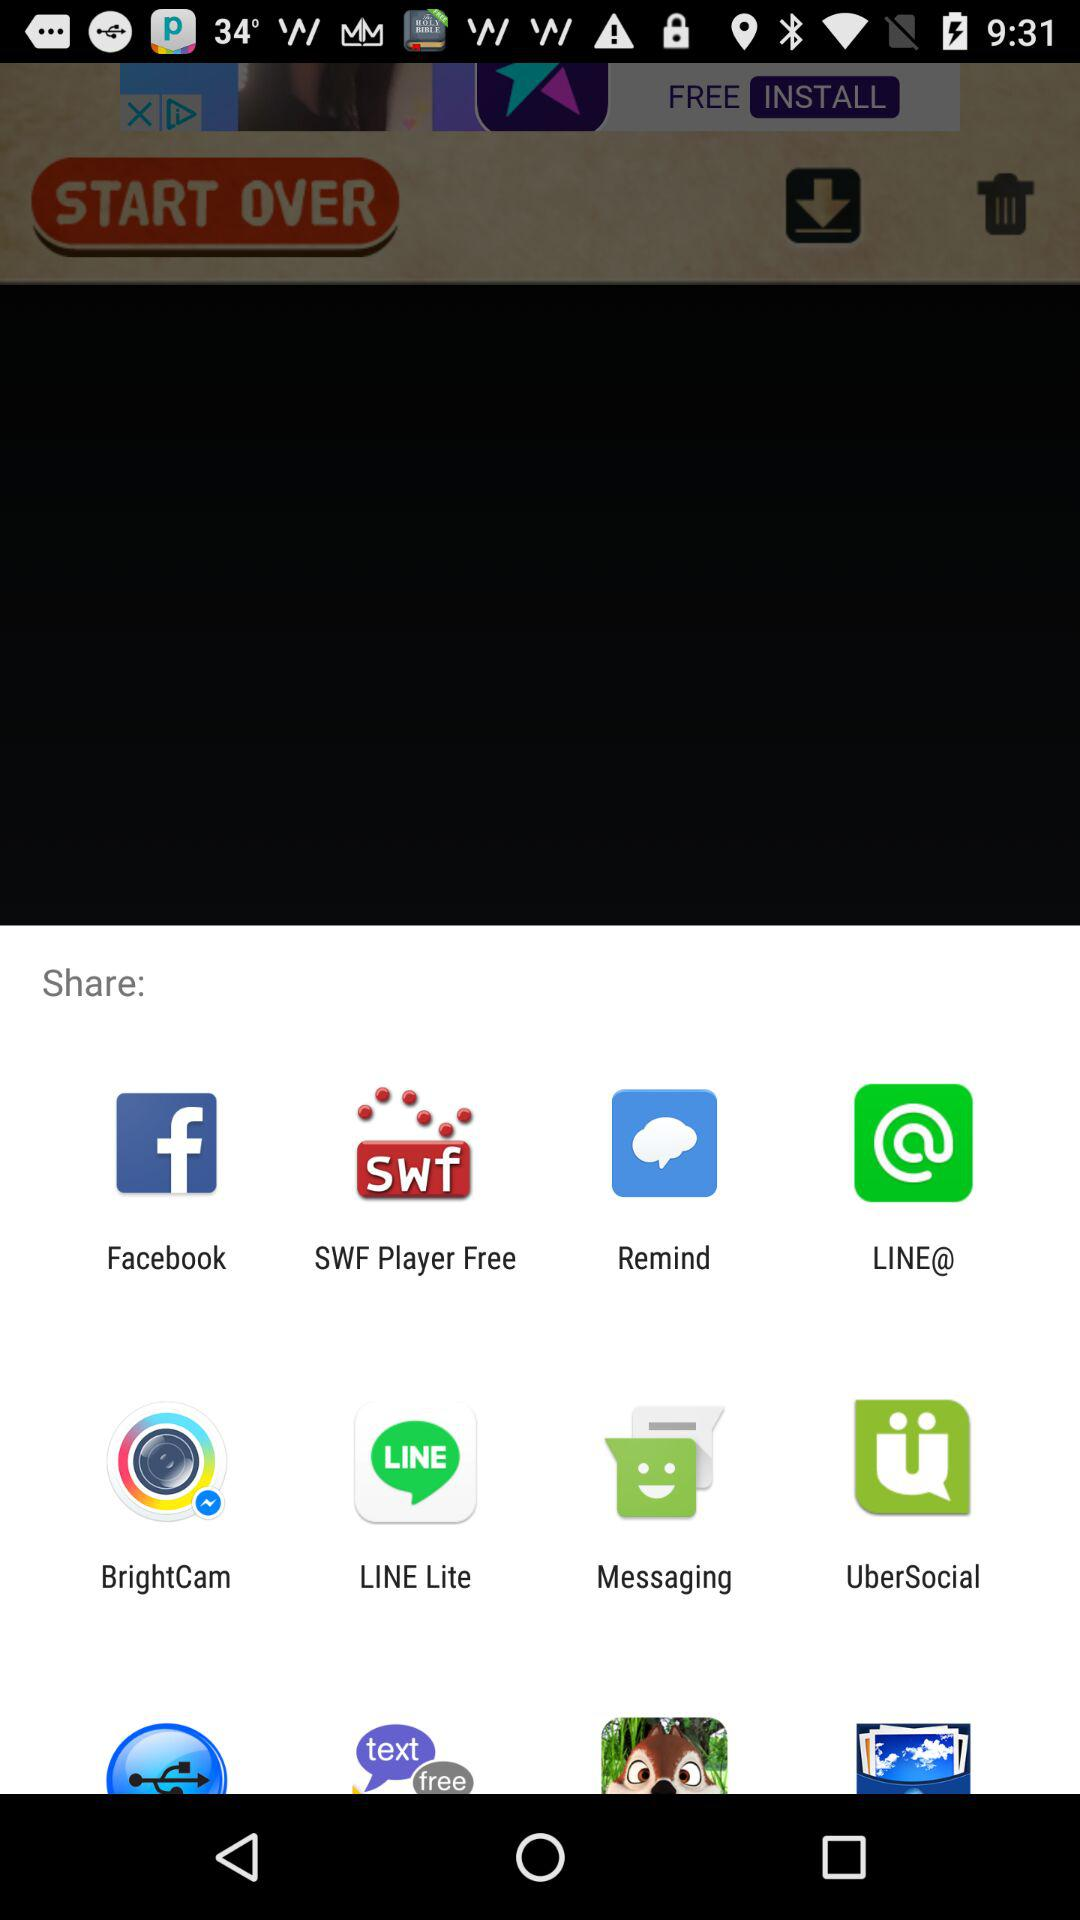By which app can we share? You can share by "Facebook", "SWF Player Free", "Remind", "LINE@", "BrightCam", "LINE Lite", "Messaging" and "UberSocial". 